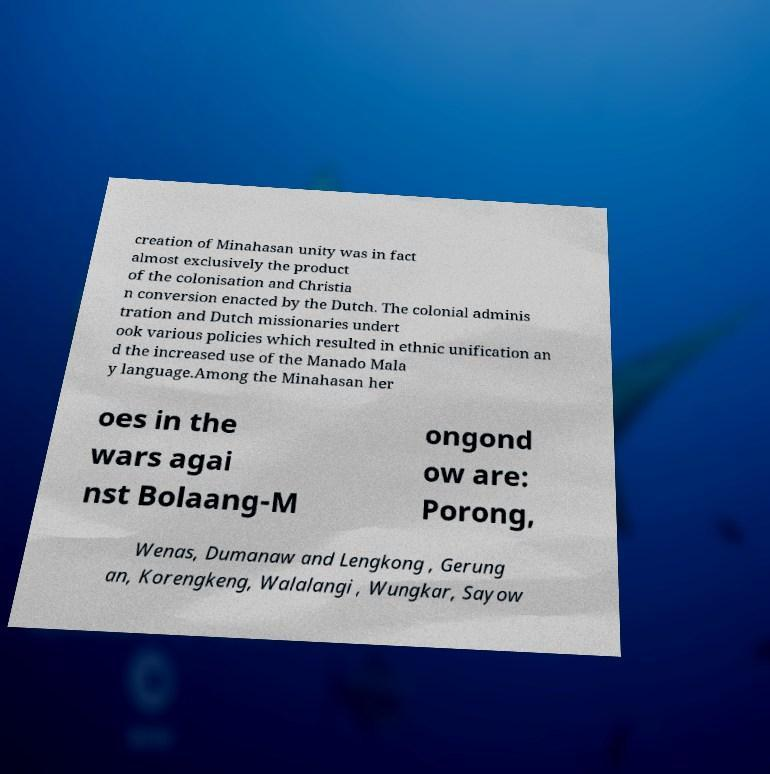Can you read and provide the text displayed in the image?This photo seems to have some interesting text. Can you extract and type it out for me? creation of Minahasan unity was in fact almost exclusively the product of the colonisation and Christia n conversion enacted by the Dutch. The colonial adminis tration and Dutch missionaries undert ook various policies which resulted in ethnic unification an d the increased use of the Manado Mala y language.Among the Minahasan her oes in the wars agai nst Bolaang-M ongond ow are: Porong, Wenas, Dumanaw and Lengkong , Gerung an, Korengkeng, Walalangi , Wungkar, Sayow 